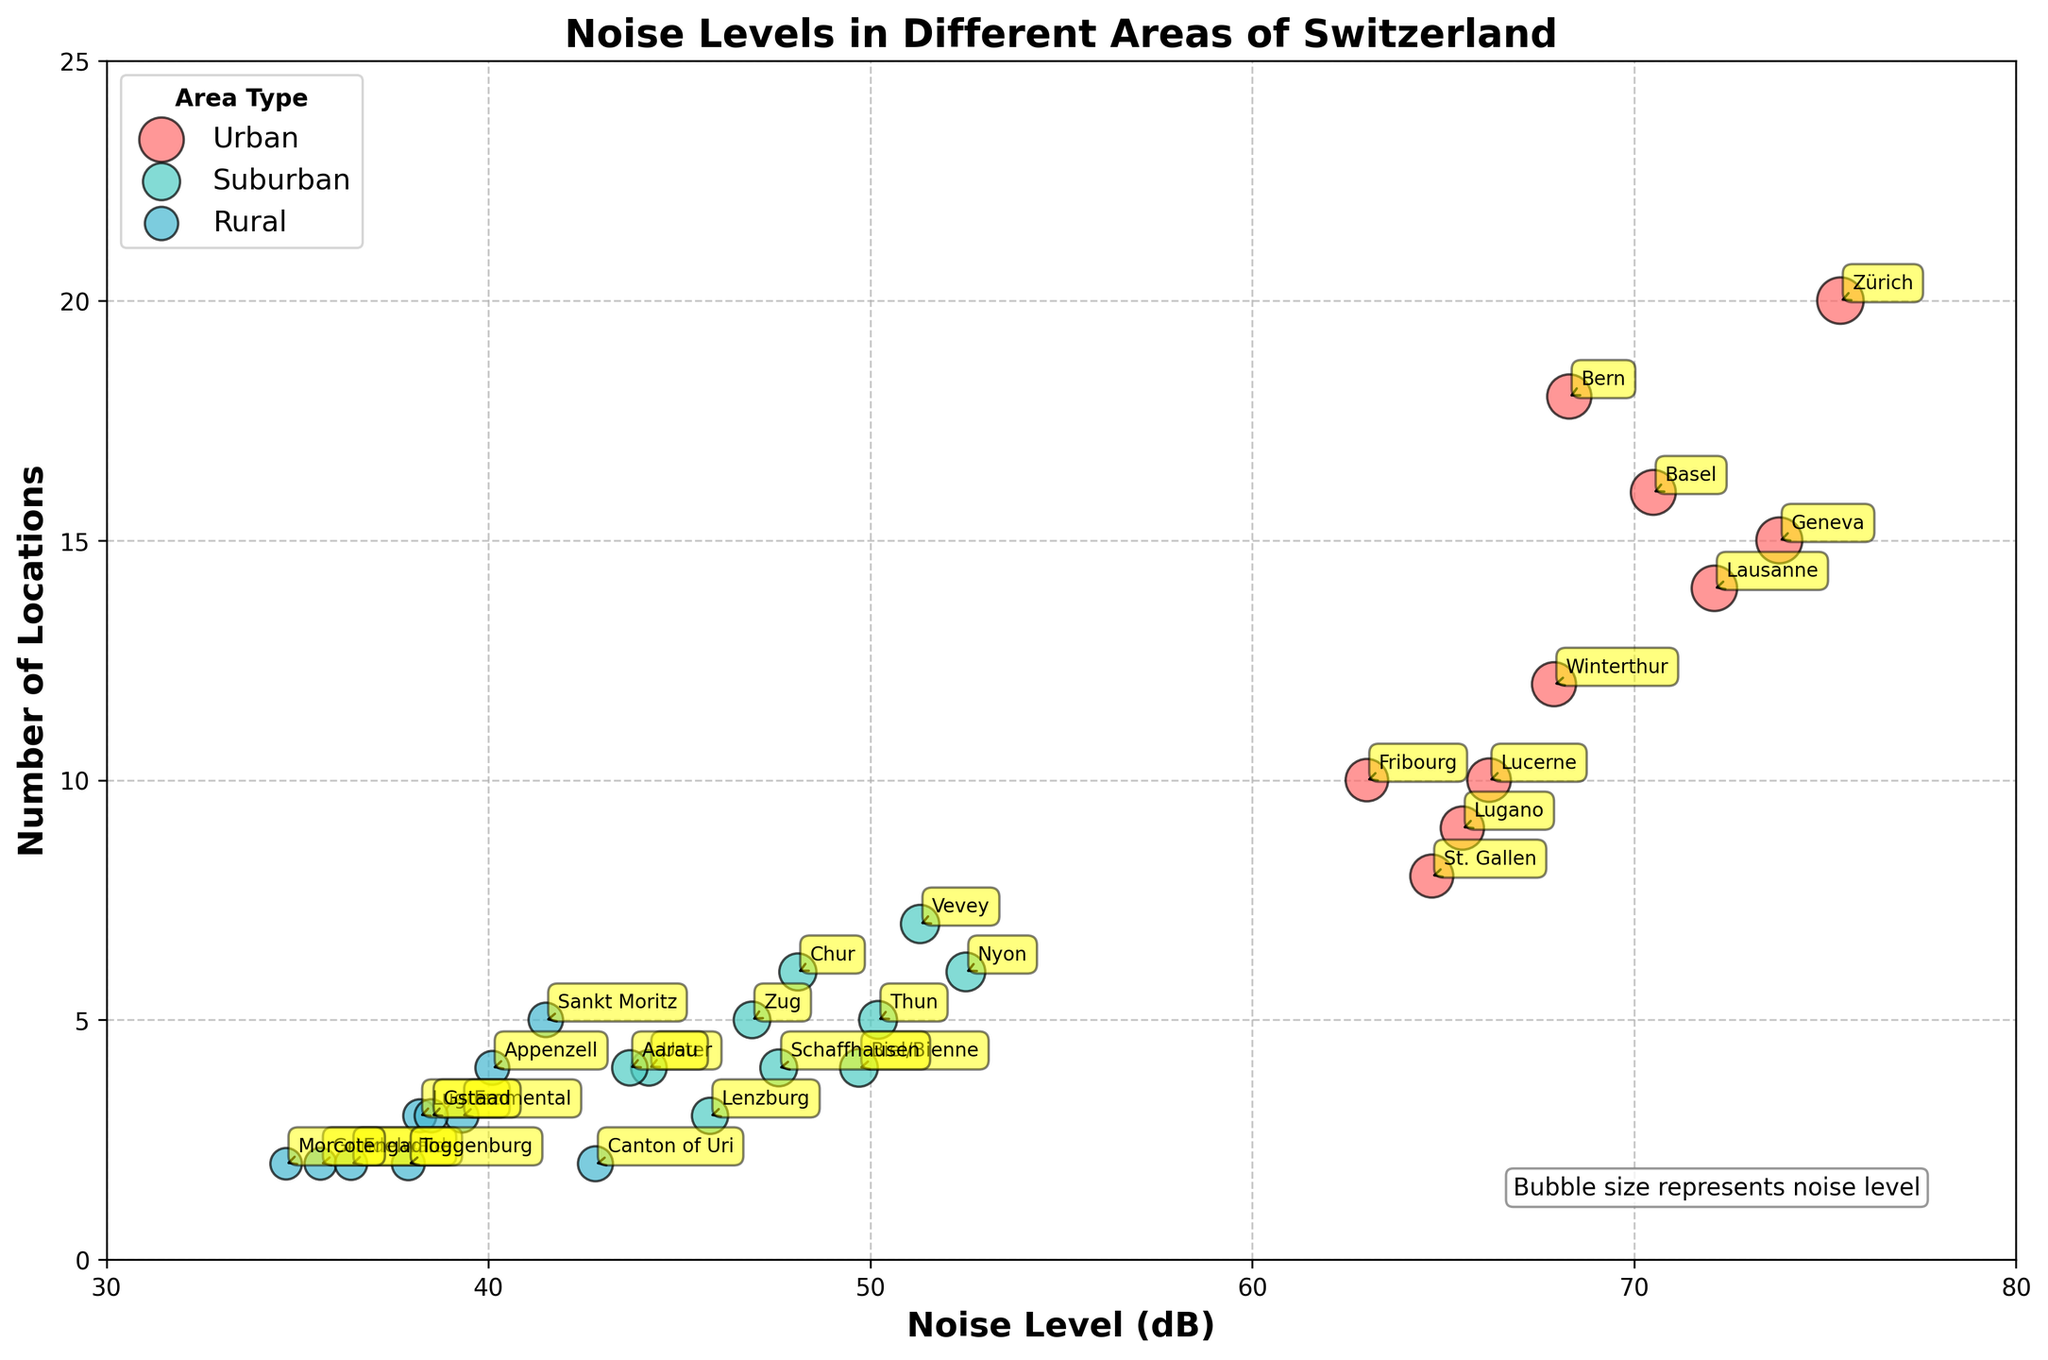What's the title of the plot? The title of the plot is written at the top center of the figure and summarizes what the plot is about.
Answer: Noise Levels in Different Areas of Switzerland What does the y-axis represent? The y-axis represents the 'Number of Locations', which is labeled on the left-hand side of the plot.
Answer: Number of Locations What is the highest noise level recorded in the urban areas? By observing the placement and size of the bubbles in the urban category, the bubble with the highest noise level will be the largest and placed furthest right. Zürich has the highest noise level at 75.4 dB.
Answer: 75.4 dB Which area has the smallest noise level recorded in the rural areas? By looking at the bubbles in the rural category, the smallest noise level is represented by the smallest bubble furthest to the left. Morcote has the smallest noise level at 34.7 dB.
Answer: Morcote at 34.7 dB How many locations are represented in Zürich? The size of the bubble and its placement on the y-axis indicate the number of locations. The Zürich bubble is situated at 20 on the y-axis, indicating 20 locations.
Answer: 20 Compare the noise levels of Geneva and Winterthur. Which is higher? The bubbles for Geneva and Winterthur can be compared by their position on the x-axis where noise levels are indicated. Geneva is at 73.8 dB, while Winterthur is at 67.9 dB.
Answer: Geneva Among suburban areas, which has the highest noise level? The largest bubble positioned farthest to the right within the suburban category represents the highest noise level. Nyon has the highest suburban noise level at 52.5 dB.
Answer: Nyon What is the difference in noise levels between Emmental and St. Gallen? Emmental's noise level is identified at 39.3 dB in the rural category, and St. Gallen's noise level is 64.7 dB in the urban category. The difference is 64.7 - 39.3 = 25.4 dB.
Answer: 25.4 dB What is the average noise level of the rural areas? The average noise level of rural areas is found by summing all rural noise levels (38.2 + 35.6 + 40.1 + 41.5 + 42.8 + 39.3 + 36.4 + 37.9 + 38.5 + 34.7 = 385) and dividing by the number of rural areas (10). 385 / 10 = 38.5 dB.
Answer: 38.5 dB Which area has the largest number of locations, and what is the noise level there? The area with the largest number of locations will have the highest value on the y-axis. Zürich has the highest number of locations at 20 and its noise level is 75.4 dB.
Answer: Zürich at 75.4 dB 